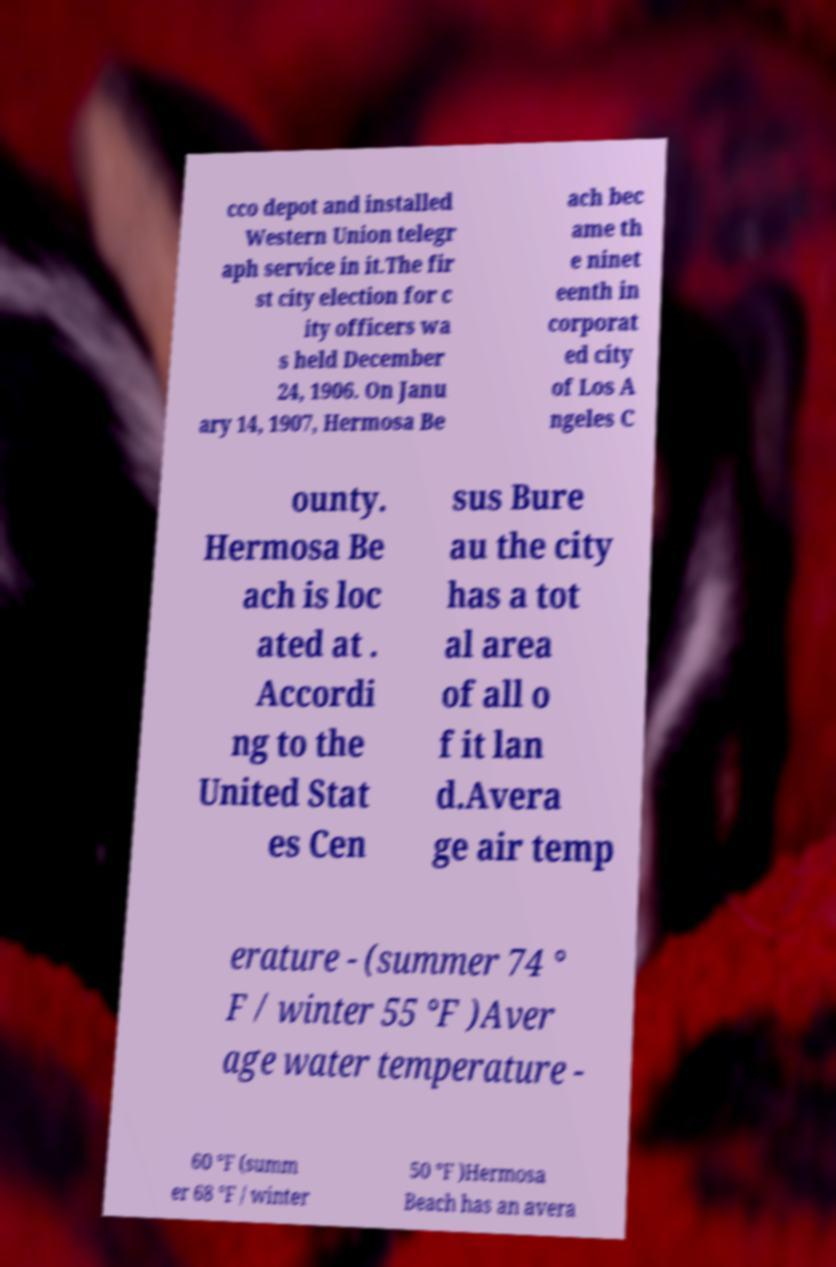There's text embedded in this image that I need extracted. Can you transcribe it verbatim? cco depot and installed Western Union telegr aph service in it.The fir st city election for c ity officers wa s held December 24, 1906. On Janu ary 14, 1907, Hermosa Be ach bec ame th e ninet eenth in corporat ed city of Los A ngeles C ounty. Hermosa Be ach is loc ated at . Accordi ng to the United Stat es Cen sus Bure au the city has a tot al area of all o f it lan d.Avera ge air temp erature - (summer 74 ° F / winter 55 °F )Aver age water temperature - 60 °F (summ er 68 °F / winter 50 °F )Hermosa Beach has an avera 